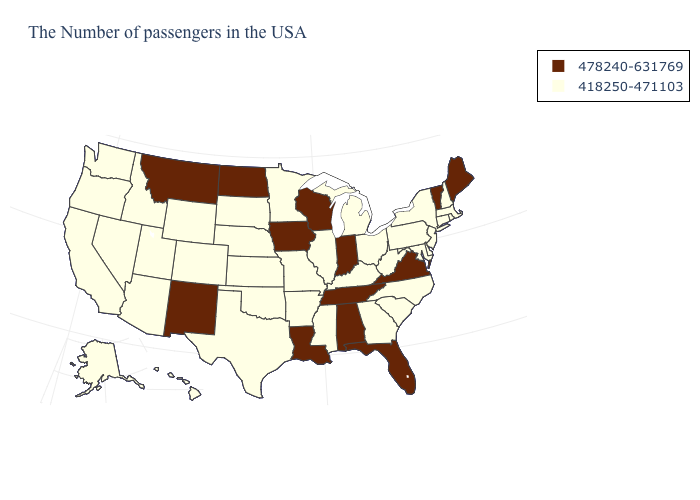Does Connecticut have the lowest value in the USA?
Be succinct. Yes. Name the states that have a value in the range 478240-631769?
Keep it brief. Maine, Vermont, Virginia, Florida, Indiana, Alabama, Tennessee, Wisconsin, Louisiana, Iowa, North Dakota, New Mexico, Montana. Name the states that have a value in the range 478240-631769?
Answer briefly. Maine, Vermont, Virginia, Florida, Indiana, Alabama, Tennessee, Wisconsin, Louisiana, Iowa, North Dakota, New Mexico, Montana. What is the lowest value in states that border Kentucky?
Write a very short answer. 418250-471103. Does the map have missing data?
Write a very short answer. No. Does West Virginia have a lower value than South Carolina?
Write a very short answer. No. Among the states that border Illinois , which have the highest value?
Be succinct. Indiana, Wisconsin, Iowa. How many symbols are there in the legend?
Concise answer only. 2. Among the states that border Ohio , does Indiana have the highest value?
Quick response, please. Yes. Is the legend a continuous bar?
Give a very brief answer. No. Name the states that have a value in the range 478240-631769?
Quick response, please. Maine, Vermont, Virginia, Florida, Indiana, Alabama, Tennessee, Wisconsin, Louisiana, Iowa, North Dakota, New Mexico, Montana. Does Tennessee have the lowest value in the USA?
Short answer required. No. What is the highest value in states that border Alabama?
Give a very brief answer. 478240-631769. What is the highest value in states that border Mississippi?
Answer briefly. 478240-631769. 